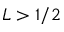Convert formula to latex. <formula><loc_0><loc_0><loc_500><loc_500>L > 1 / 2</formula> 